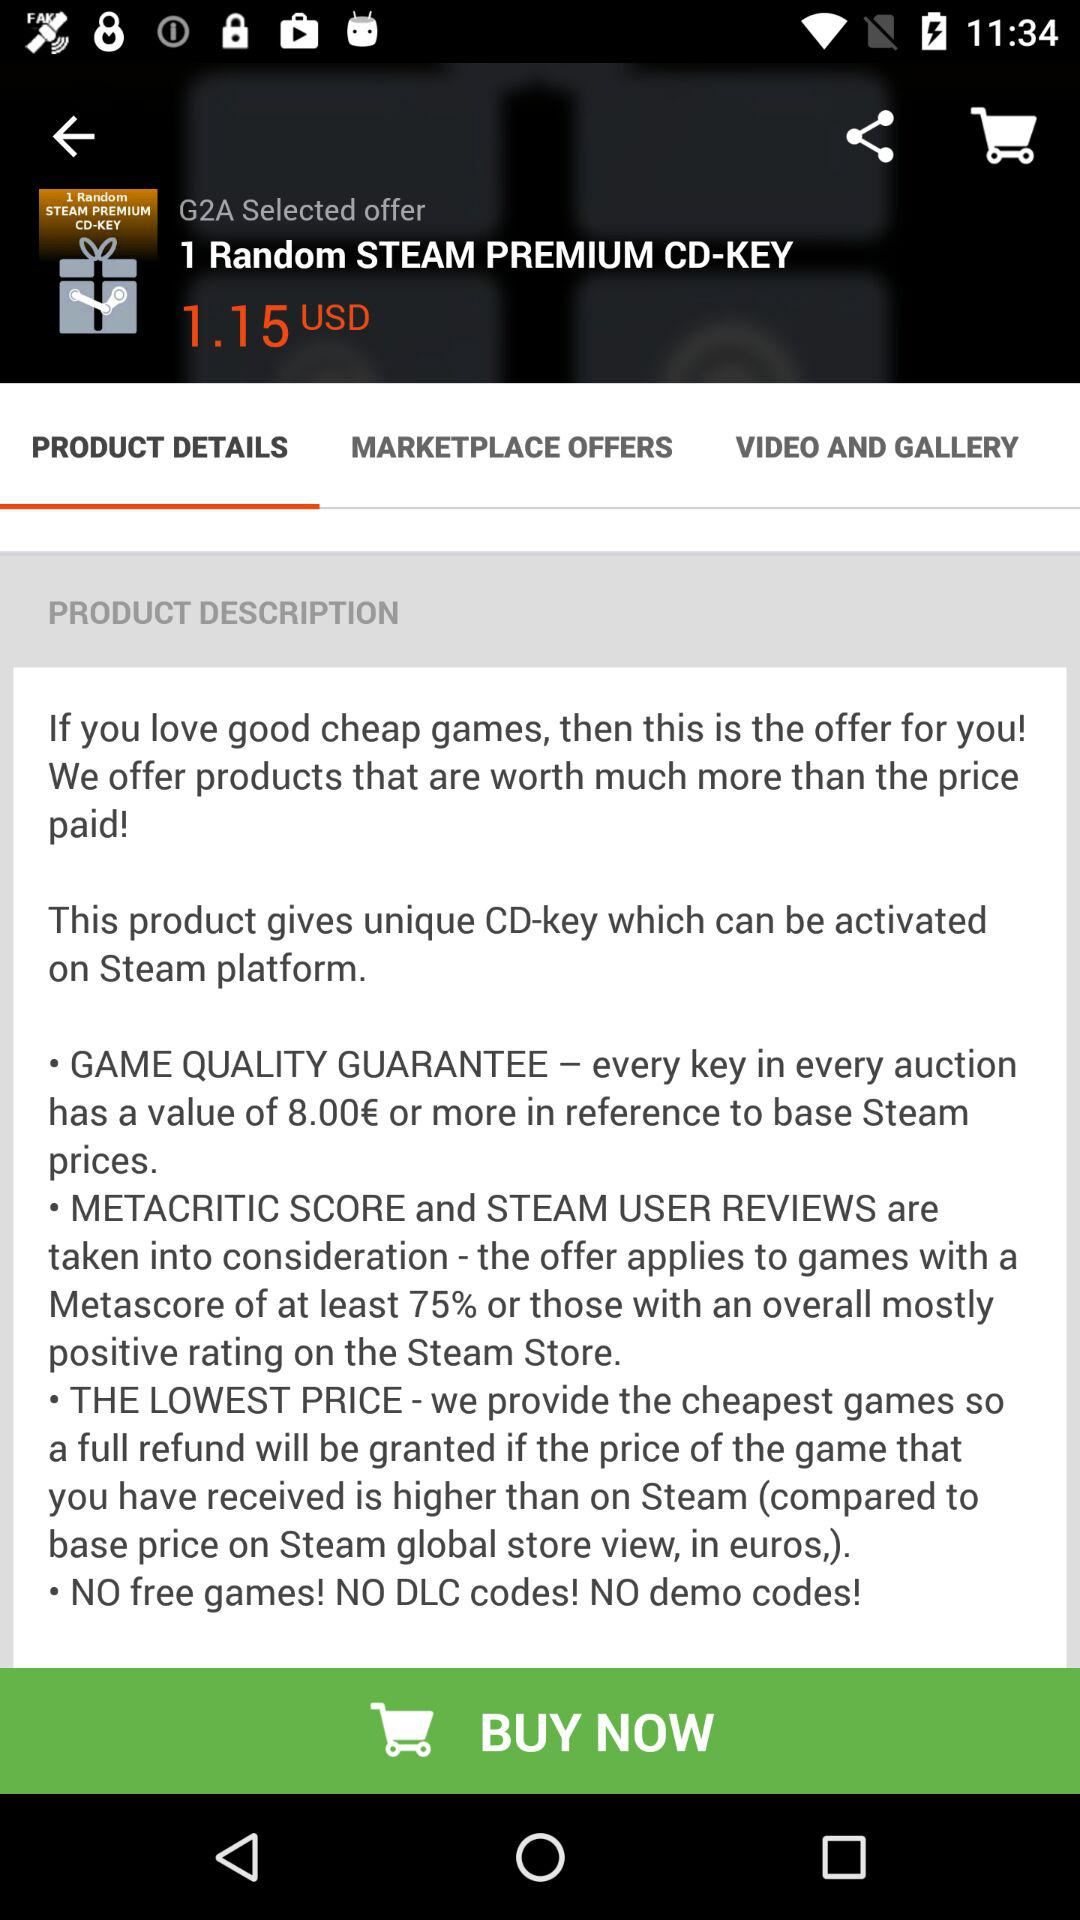How much is the value in USD of every key in every auction?
When the provided information is insufficient, respond with <no answer>. <no answer> 